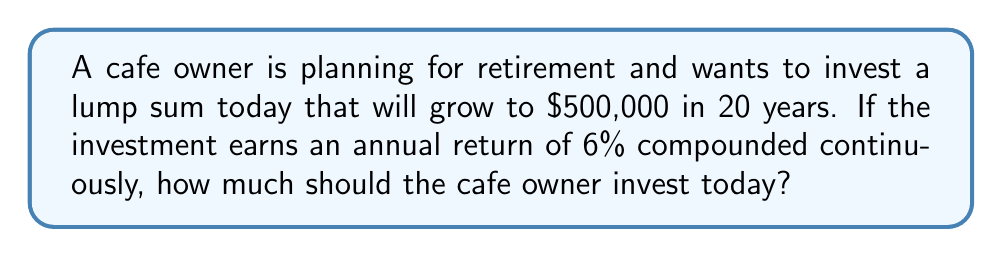Provide a solution to this math problem. To solve this problem, we need to use the formula for continuous compound interest:

$$A = P e^{rt}$$

Where:
$A$ = Final amount
$P$ = Principal (initial investment)
$r$ = Annual interest rate (as a decimal)
$t$ = Time in years
$e$ = Euler's number (approximately 2.71828)

We know:
$A = \$500,000$
$r = 0.06$ (6% expressed as a decimal)
$t = 20$ years

We need to solve for $P$. Rearranging the formula:

$$P = A e^{-rt}$$

Plugging in the values:

$$P = 500,000 \cdot e^{-0.06 \cdot 20}$$

$$P = 500,000 \cdot e^{-1.2}$$

Using a calculator or computer:

$$P = 500,000 \cdot 0.301194$$

$$P = 150,597$$

Therefore, the cafe owner needs to invest approximately $150,597 today to reach the goal of $500,000 in 20 years, assuming a 6% annual return compounded continuously.
Answer: $150,597 